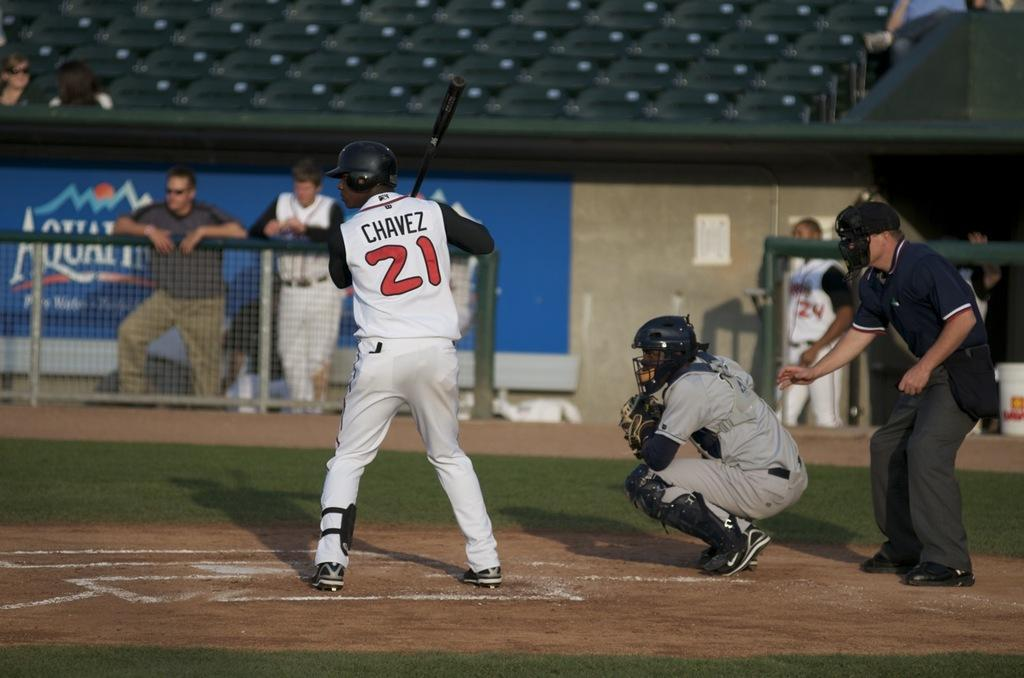<image>
Relay a brief, clear account of the picture shown. a number 21 that is on a shirt of a player 